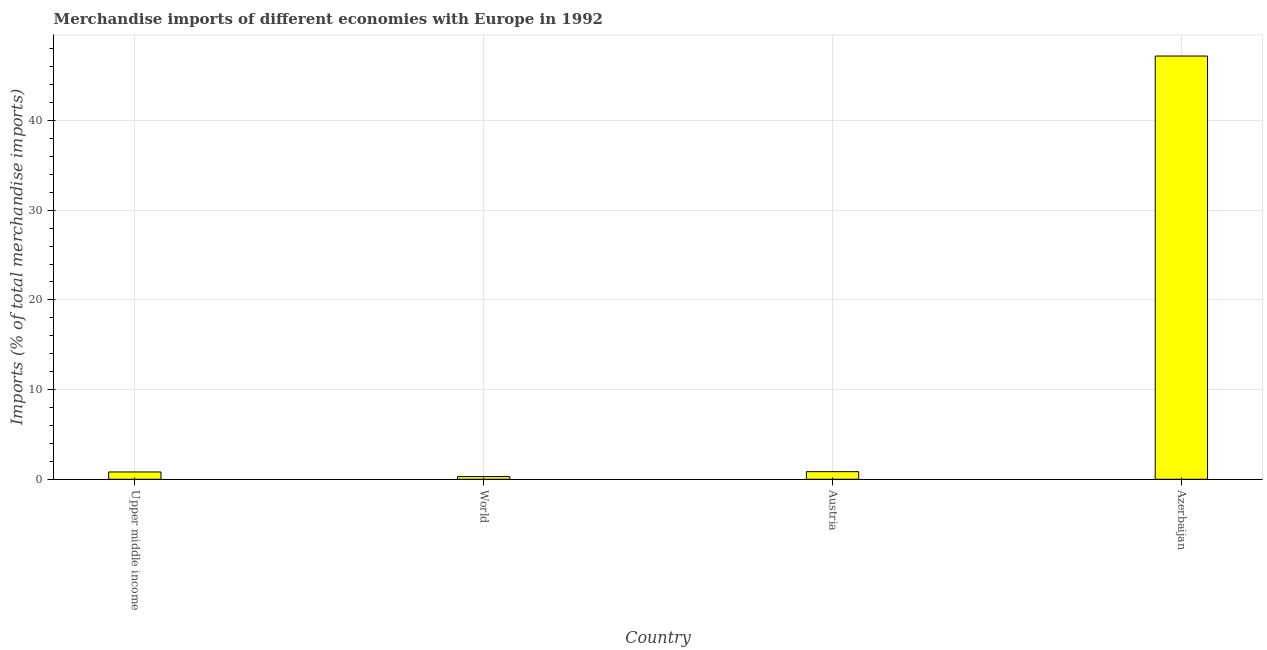Does the graph contain any zero values?
Your response must be concise. No. What is the title of the graph?
Offer a very short reply. Merchandise imports of different economies with Europe in 1992. What is the label or title of the Y-axis?
Your answer should be very brief. Imports (% of total merchandise imports). What is the merchandise imports in Azerbaijan?
Keep it short and to the point. 47.2. Across all countries, what is the maximum merchandise imports?
Keep it short and to the point. 47.2. Across all countries, what is the minimum merchandise imports?
Provide a short and direct response. 0.3. In which country was the merchandise imports maximum?
Provide a short and direct response. Azerbaijan. In which country was the merchandise imports minimum?
Give a very brief answer. World. What is the sum of the merchandise imports?
Your answer should be very brief. 49.16. What is the difference between the merchandise imports in Azerbaijan and Upper middle income?
Offer a very short reply. 46.38. What is the average merchandise imports per country?
Your answer should be very brief. 12.29. What is the median merchandise imports?
Keep it short and to the point. 0.83. What is the ratio of the merchandise imports in Azerbaijan to that in Upper middle income?
Provide a succinct answer. 57.92. What is the difference between the highest and the second highest merchandise imports?
Your response must be concise. 46.35. What is the difference between the highest and the lowest merchandise imports?
Offer a terse response. 46.9. In how many countries, is the merchandise imports greater than the average merchandise imports taken over all countries?
Offer a terse response. 1. Are all the bars in the graph horizontal?
Your answer should be very brief. No. How many countries are there in the graph?
Offer a terse response. 4. What is the Imports (% of total merchandise imports) in Upper middle income?
Give a very brief answer. 0.81. What is the Imports (% of total merchandise imports) in World?
Give a very brief answer. 0.3. What is the Imports (% of total merchandise imports) in Austria?
Ensure brevity in your answer.  0.85. What is the Imports (% of total merchandise imports) of Azerbaijan?
Give a very brief answer. 47.2. What is the difference between the Imports (% of total merchandise imports) in Upper middle income and World?
Give a very brief answer. 0.52. What is the difference between the Imports (% of total merchandise imports) in Upper middle income and Austria?
Provide a short and direct response. -0.03. What is the difference between the Imports (% of total merchandise imports) in Upper middle income and Azerbaijan?
Offer a terse response. -46.38. What is the difference between the Imports (% of total merchandise imports) in World and Austria?
Offer a terse response. -0.55. What is the difference between the Imports (% of total merchandise imports) in World and Azerbaijan?
Your answer should be compact. -46.9. What is the difference between the Imports (% of total merchandise imports) in Austria and Azerbaijan?
Your response must be concise. -46.35. What is the ratio of the Imports (% of total merchandise imports) in Upper middle income to that in World?
Provide a short and direct response. 2.72. What is the ratio of the Imports (% of total merchandise imports) in Upper middle income to that in Azerbaijan?
Your answer should be compact. 0.02. What is the ratio of the Imports (% of total merchandise imports) in World to that in Austria?
Provide a short and direct response. 0.35. What is the ratio of the Imports (% of total merchandise imports) in World to that in Azerbaijan?
Offer a very short reply. 0.01. What is the ratio of the Imports (% of total merchandise imports) in Austria to that in Azerbaijan?
Provide a short and direct response. 0.02. 